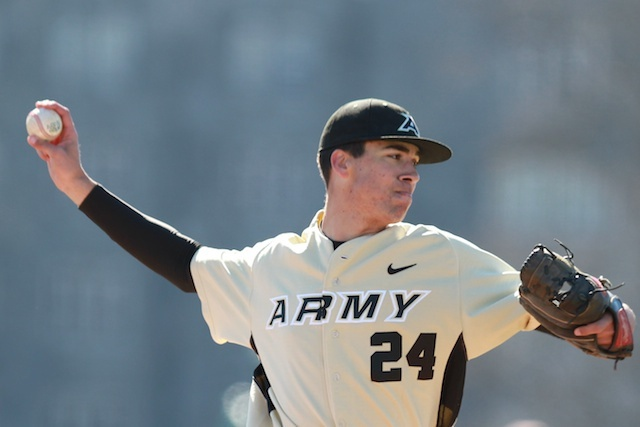Describe the objects in this image and their specific colors. I can see people in gray, black, darkgray, tan, and lightgray tones, baseball glove in gray, black, maroon, and brown tones, and sports ball in gray, darkgray, tan, and lightgray tones in this image. 